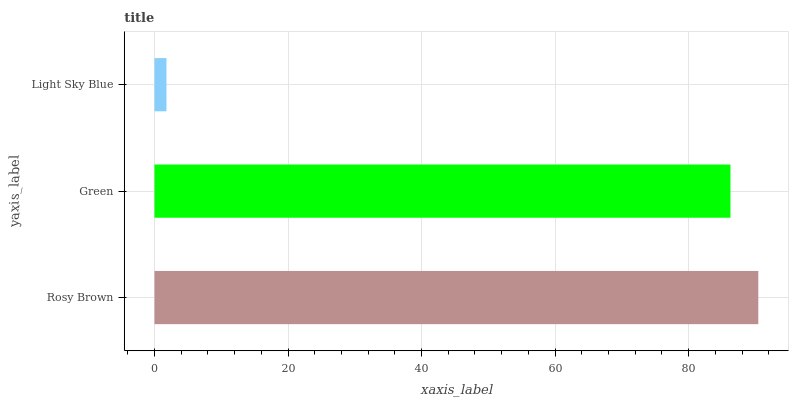Is Light Sky Blue the minimum?
Answer yes or no. Yes. Is Rosy Brown the maximum?
Answer yes or no. Yes. Is Green the minimum?
Answer yes or no. No. Is Green the maximum?
Answer yes or no. No. Is Rosy Brown greater than Green?
Answer yes or no. Yes. Is Green less than Rosy Brown?
Answer yes or no. Yes. Is Green greater than Rosy Brown?
Answer yes or no. No. Is Rosy Brown less than Green?
Answer yes or no. No. Is Green the high median?
Answer yes or no. Yes. Is Green the low median?
Answer yes or no. Yes. Is Rosy Brown the high median?
Answer yes or no. No. Is Light Sky Blue the low median?
Answer yes or no. No. 